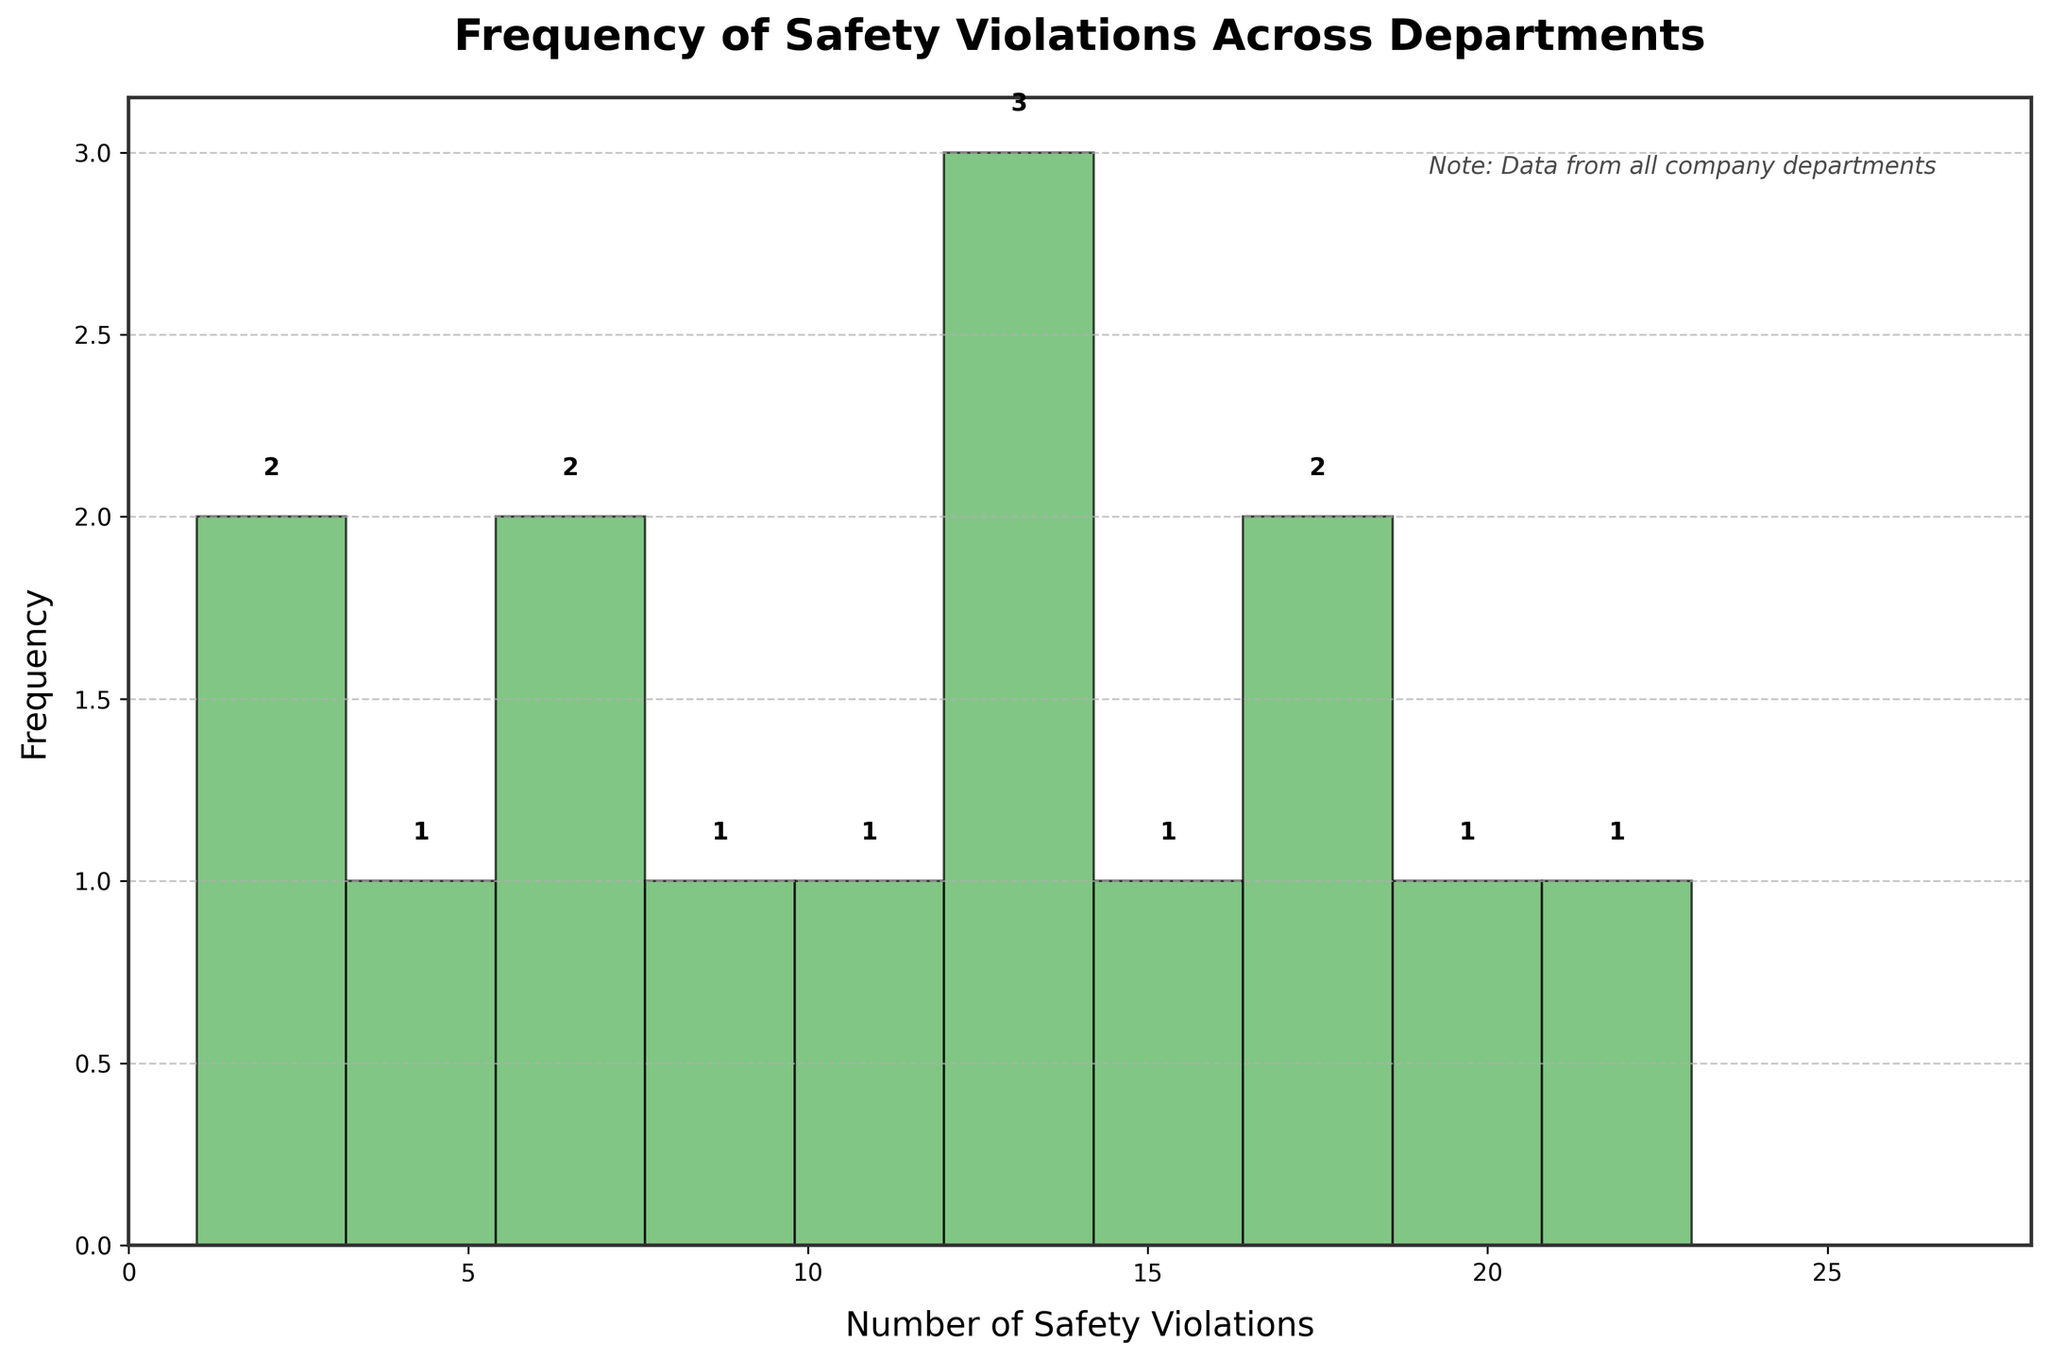How many departments have between 10 and 15 safety violations? We look at the histogram bin that ranges from 10 to 15 safety violations. By counting the frequencies displayed in this range, there are four departments.
Answer: Four departments Which department has the highest number of safety violations? From the data provided, the Assembly Line department has the highest number of safety violations with 23.
Answer: Assembly Line What's the total number of safety violations across all departments? Sum all the individual safety violations from the data table: 23 + 18 + 12 + 15 + 7 + 4 + 9 + 2 + 1 + 6 + 20 + 17 + 14 + 11 + 13 = 172
Answer: 172 What's the range of safety violations in the departments? The range is calculated by subtracting the minimum value from the maximum value in the data set. The minimum is 1 (Administration), and the maximum is 23 (Assembly Line), so the range is 23 - 1 = 22.
Answer: 22 Which bins have the highest frequency in the histogram? By observing the histogram, the bins with the range from 0 to 5 have the highest frequency, containing four departments (Human Resources, Administration, Engineering, Research and Development).
Answer: 0-5 What is the average number of safety violations per department? To find the average, divide the total number of violations by the number of departments. The total number is 172, and there are 15 departments, so the average is 172/15 ≈ 11.47.
Answer: 11.47 Which department has the second-highest number of safety violations? From the data provided, Chemical Processing has the second-highest number of safety violations with 20.
Answer: Chemical Processing How many departments have fewer than 10 safety violations? From the histogram, count the number of departments across bins representing values less than 10. There are 7 such departments (Research and Development, Quality Control, Shipping and Receiving, Human Resources, Administration, Engineering).
Answer: Seven departments Compare violations between the Maintenance and Welding departments. Which one has more? Since Welding (17 violations) has more violations than Maintenance (15 violations), Welding has more.
Answer: Welding How many violations do the top three violating departments account for? Sum the violations of the top three departments: Assembly Line (23), Chemical Processing (20), Warehouse (18). The total is 23 + 20 + 18 = 61.
Answer: 61 